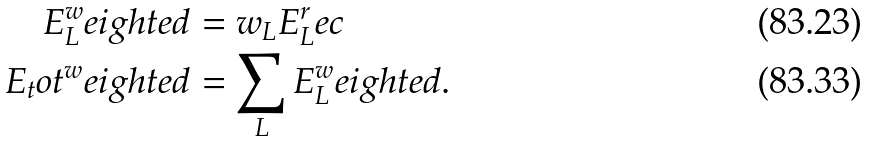<formula> <loc_0><loc_0><loc_500><loc_500>E _ { L } ^ { w } e i g h t e d & = w _ { L } E _ { L } ^ { r } e c \\ E _ { t } o t ^ { w } e i g h t e d & = \sum _ { L } E _ { L } ^ { w } e i g h t e d .</formula> 